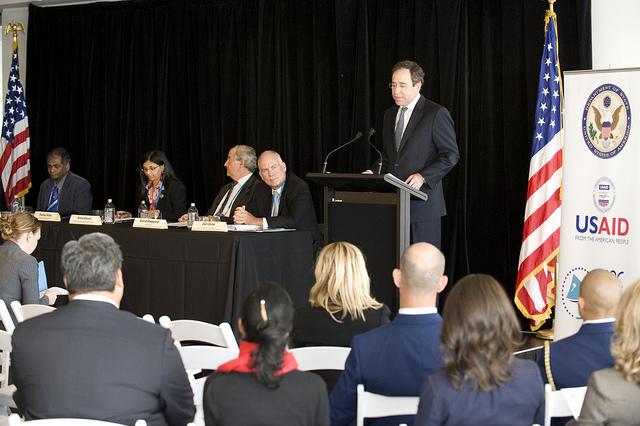What is the man at the podium doing?
Quick response, please. Speaking. What is the company name on the banner?
Write a very short answer. Usaid. Which countries flags are on display?
Keep it brief. Usa. 